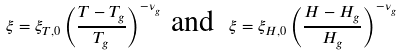Convert formula to latex. <formula><loc_0><loc_0><loc_500><loc_500>\xi = \xi _ { T , 0 } \left ( \frac { T - T _ { g } } { T _ { g } } \right ) ^ { - \nu _ { g } } \text { and } \ \xi = \xi _ { H , 0 } \left ( \frac { H - H _ { g } } { H _ { g } } \right ) ^ { - \nu _ { g } }</formula> 